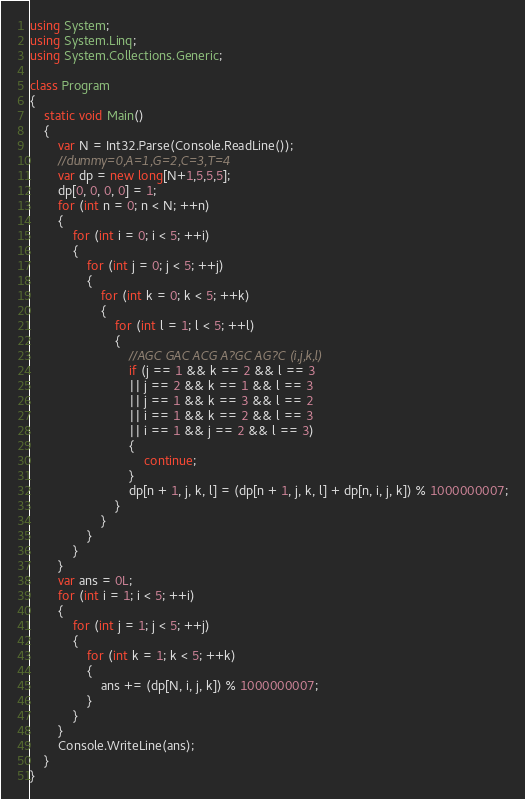<code> <loc_0><loc_0><loc_500><loc_500><_C#_>using System;
using System.Linq;
using System.Collections.Generic;

class Program
{
    static void Main()
    {
        var N = Int32.Parse(Console.ReadLine());
        //dummy=0,A=1,G=2,C=3,T=4
        var dp = new long[N+1,5,5,5];
        dp[0, 0, 0, 0] = 1;
        for (int n = 0; n < N; ++n)
        {
            for (int i = 0; i < 5; ++i)
            {
                for (int j = 0; j < 5; ++j)
                {
                    for (int k = 0; k < 5; ++k)
                    {
                        for (int l = 1; l < 5; ++l)
                        {
                            //AGC GAC ACG A?GC AG?C (i,j,k,l)
                            if (j == 1 && k == 2 && l == 3
                            || j == 2 && k == 1 && l == 3
                            || j == 1 && k == 3 && l == 2
                            || i == 1 && k == 2 && l == 3
                            || i == 1 && j == 2 && l == 3)
                            {
                                continue;
                            }
                            dp[n + 1, j, k, l] = (dp[n + 1, j, k, l] + dp[n, i, j, k]) % 1000000007;
                        }
                    }
                }
            }
        }
        var ans = 0L;
        for (int i = 1; i < 5; ++i)
        {
            for (int j = 1; j < 5; ++j)
            {
                for (int k = 1; k < 5; ++k)
                {
                    ans += (dp[N, i, j, k]) % 1000000007;
                }
            }
        }
        Console.WriteLine(ans);
    }
}
</code> 